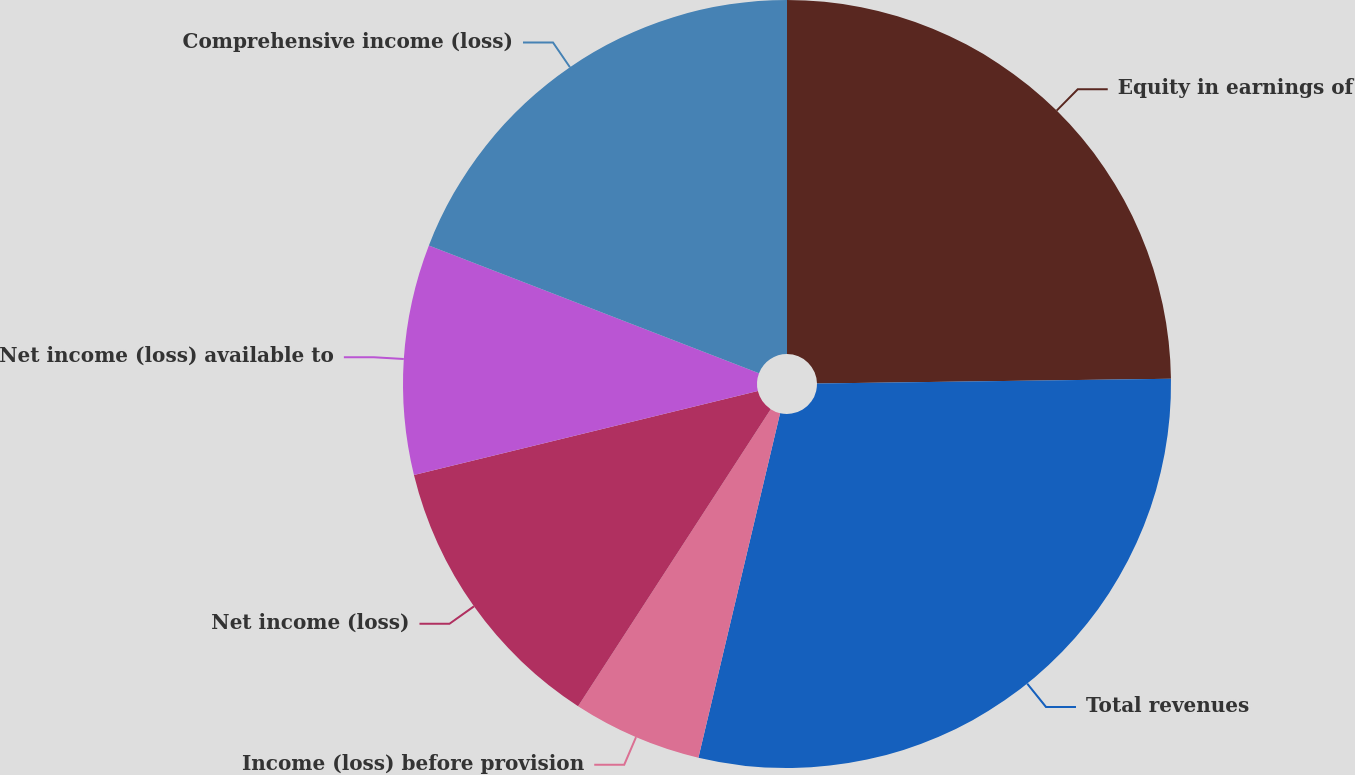<chart> <loc_0><loc_0><loc_500><loc_500><pie_chart><fcel>Equity in earnings of<fcel>Total revenues<fcel>Income (loss) before provision<fcel>Net income (loss)<fcel>Net income (loss) available to<fcel>Comprehensive income (loss)<nl><fcel>24.78%<fcel>28.92%<fcel>5.45%<fcel>12.03%<fcel>9.69%<fcel>19.12%<nl></chart> 